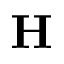<formula> <loc_0><loc_0><loc_500><loc_500>H</formula> 